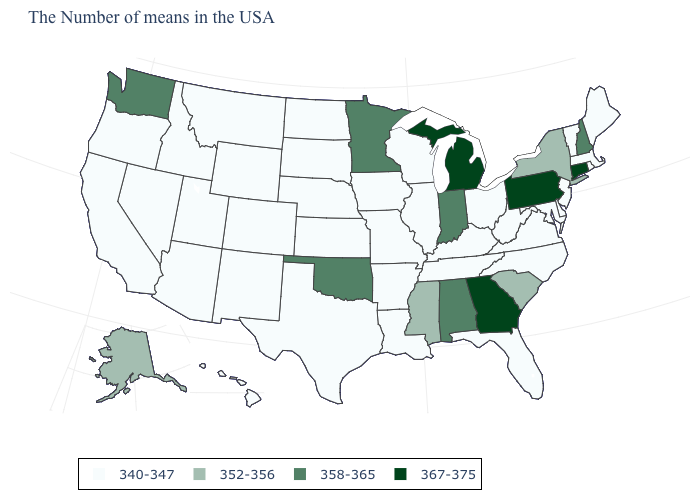What is the value of Vermont?
Be succinct. 340-347. Is the legend a continuous bar?
Quick response, please. No. Among the states that border Pennsylvania , which have the highest value?
Short answer required. New York. What is the value of Mississippi?
Give a very brief answer. 352-356. What is the lowest value in states that border Virginia?
Quick response, please. 340-347. What is the lowest value in states that border Pennsylvania?
Write a very short answer. 340-347. Name the states that have a value in the range 367-375?
Concise answer only. Connecticut, Pennsylvania, Georgia, Michigan. Name the states that have a value in the range 358-365?
Answer briefly. New Hampshire, Indiana, Alabama, Minnesota, Oklahoma, Washington. What is the value of Oklahoma?
Quick response, please. 358-365. Among the states that border Florida , does Alabama have the highest value?
Keep it brief. No. Name the states that have a value in the range 340-347?
Write a very short answer. Maine, Massachusetts, Rhode Island, Vermont, New Jersey, Delaware, Maryland, Virginia, North Carolina, West Virginia, Ohio, Florida, Kentucky, Tennessee, Wisconsin, Illinois, Louisiana, Missouri, Arkansas, Iowa, Kansas, Nebraska, Texas, South Dakota, North Dakota, Wyoming, Colorado, New Mexico, Utah, Montana, Arizona, Idaho, Nevada, California, Oregon, Hawaii. Name the states that have a value in the range 367-375?
Be succinct. Connecticut, Pennsylvania, Georgia, Michigan. Among the states that border Vermont , does New York have the highest value?
Concise answer only. No. How many symbols are there in the legend?
Quick response, please. 4. 